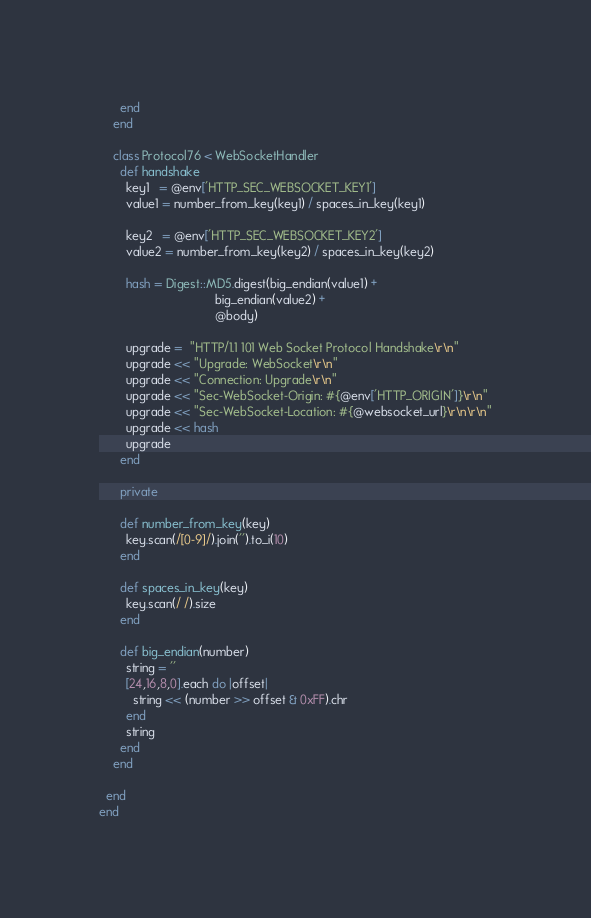Convert code to text. <code><loc_0><loc_0><loc_500><loc_500><_Ruby_>      end
    end

    class Protocol76 < WebSocketHandler
      def handshake
        key1   = @env['HTTP_SEC_WEBSOCKET_KEY1']
        value1 = number_from_key(key1) / spaces_in_key(key1)

        key2   = @env['HTTP_SEC_WEBSOCKET_KEY2']
        value2 = number_from_key(key2) / spaces_in_key(key2)

        hash = Digest::MD5.digest(big_endian(value1) +
                                  big_endian(value2) +
                                  @body)

        upgrade =  "HTTP/1.1 101 Web Socket Protocol Handshake\r\n"
        upgrade << "Upgrade: WebSocket\r\n"
        upgrade << "Connection: Upgrade\r\n"
        upgrade << "Sec-WebSocket-Origin: #{@env['HTTP_ORIGIN']}\r\n"
        upgrade << "Sec-WebSocket-Location: #{@websocket_url}\r\n\r\n"
        upgrade << hash
        upgrade
      end

      private

      def number_from_key(key)
        key.scan(/[0-9]/).join('').to_i(10)
      end

      def spaces_in_key(key)
        key.scan(/ /).size
      end

      def big_endian(number)
        string = ''
        [24,16,8,0].each do |offset|
          string << (number >> offset & 0xFF).chr
        end
        string
      end
    end

  end
end
</code> 